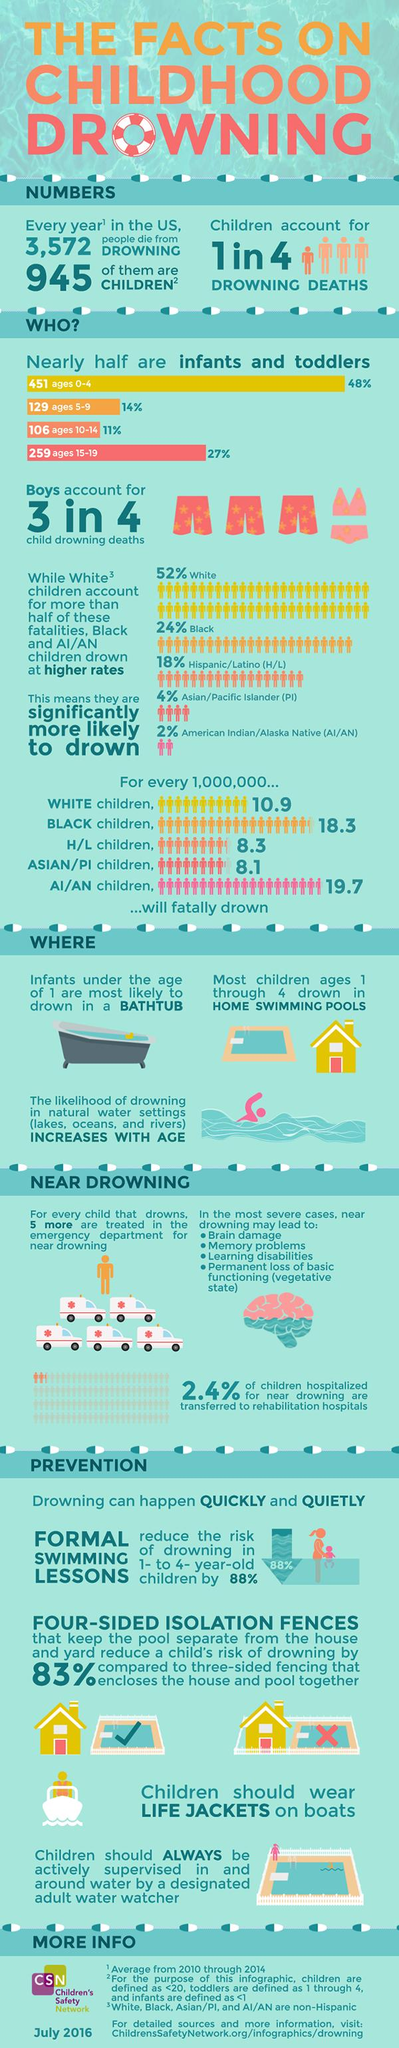Draw attention to some important aspects in this diagram. Among children, the second highest drowning death rates are reported in the age group of 15 to 19 years old. According to statistics, of all drowning deaths, approximately 75% involve boys. Formal swimming lessons can significantly reduce the risk of drowning by 88%. It is suggested that children on boats wear personal protective equipment (PPE), specifically life jackets, to ensure their safety while on the vessel. There were 580 deaths in the age group 0-9. 